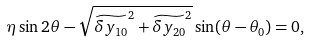<formula> <loc_0><loc_0><loc_500><loc_500>\eta \sin 2 \theta - \sqrt { \widetilde { \delta y _ { 1 0 } } ^ { 2 } + \widetilde { \delta y _ { 2 0 } } ^ { 2 } } \sin ( \theta - \theta _ { 0 } ) = 0 ,</formula> 